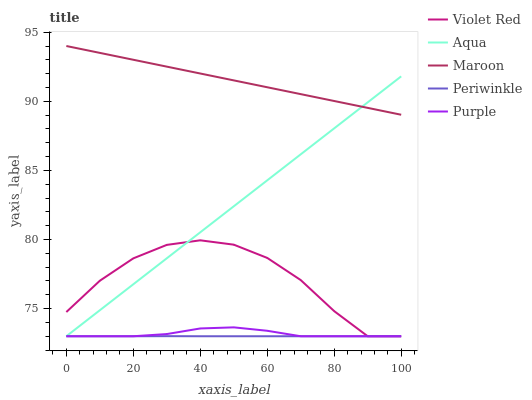Does Periwinkle have the minimum area under the curve?
Answer yes or no. Yes. Does Maroon have the maximum area under the curve?
Answer yes or no. Yes. Does Violet Red have the minimum area under the curve?
Answer yes or no. No. Does Violet Red have the maximum area under the curve?
Answer yes or no. No. Is Aqua the smoothest?
Answer yes or no. Yes. Is Violet Red the roughest?
Answer yes or no. Yes. Is Periwinkle the smoothest?
Answer yes or no. No. Is Periwinkle the roughest?
Answer yes or no. No. Does Maroon have the lowest value?
Answer yes or no. No. Does Maroon have the highest value?
Answer yes or no. Yes. Does Violet Red have the highest value?
Answer yes or no. No. Is Violet Red less than Maroon?
Answer yes or no. Yes. Is Maroon greater than Purple?
Answer yes or no. Yes. Does Purple intersect Periwinkle?
Answer yes or no. Yes. Is Purple less than Periwinkle?
Answer yes or no. No. Is Purple greater than Periwinkle?
Answer yes or no. No. Does Violet Red intersect Maroon?
Answer yes or no. No. 